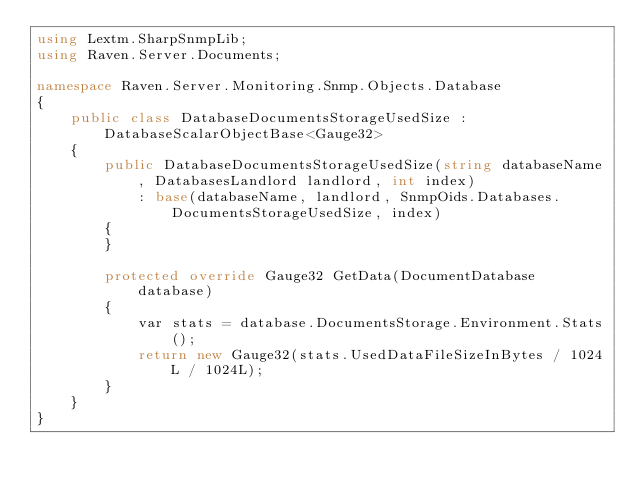Convert code to text. <code><loc_0><loc_0><loc_500><loc_500><_C#_>using Lextm.SharpSnmpLib;
using Raven.Server.Documents;

namespace Raven.Server.Monitoring.Snmp.Objects.Database
{
    public class DatabaseDocumentsStorageUsedSize : DatabaseScalarObjectBase<Gauge32>
    {
        public DatabaseDocumentsStorageUsedSize(string databaseName, DatabasesLandlord landlord, int index)
            : base(databaseName, landlord, SnmpOids.Databases.DocumentsStorageUsedSize, index)
        {
        }

        protected override Gauge32 GetData(DocumentDatabase database)
        {
            var stats = database.DocumentsStorage.Environment.Stats();
            return new Gauge32(stats.UsedDataFileSizeInBytes / 1024L / 1024L);
        }
    }
}
</code> 